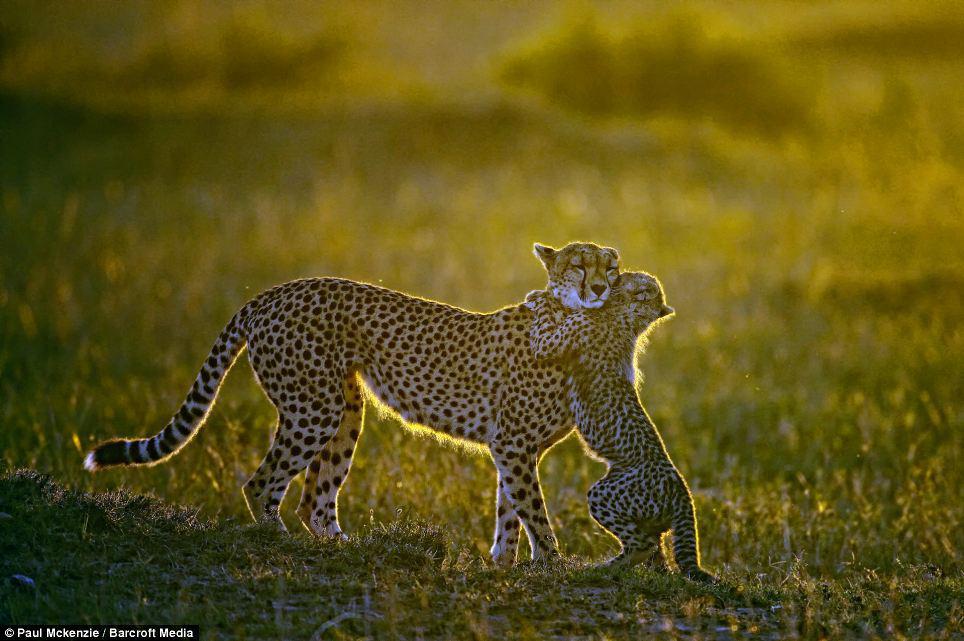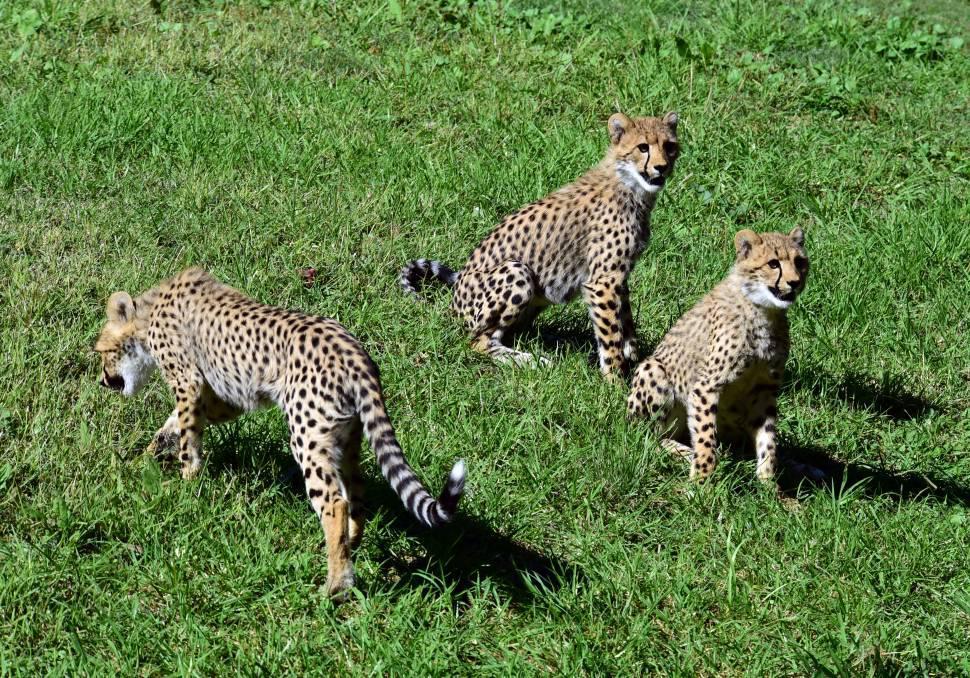The first image is the image on the left, the second image is the image on the right. For the images shown, is this caption "There are exactly eight cheetahs." true? Answer yes or no. No. The first image is the image on the left, the second image is the image on the right. For the images displayed, is the sentence "An image contains only a non-standing adult wild cat and one kitten, posed with their faces close together." factually correct? Answer yes or no. No. 